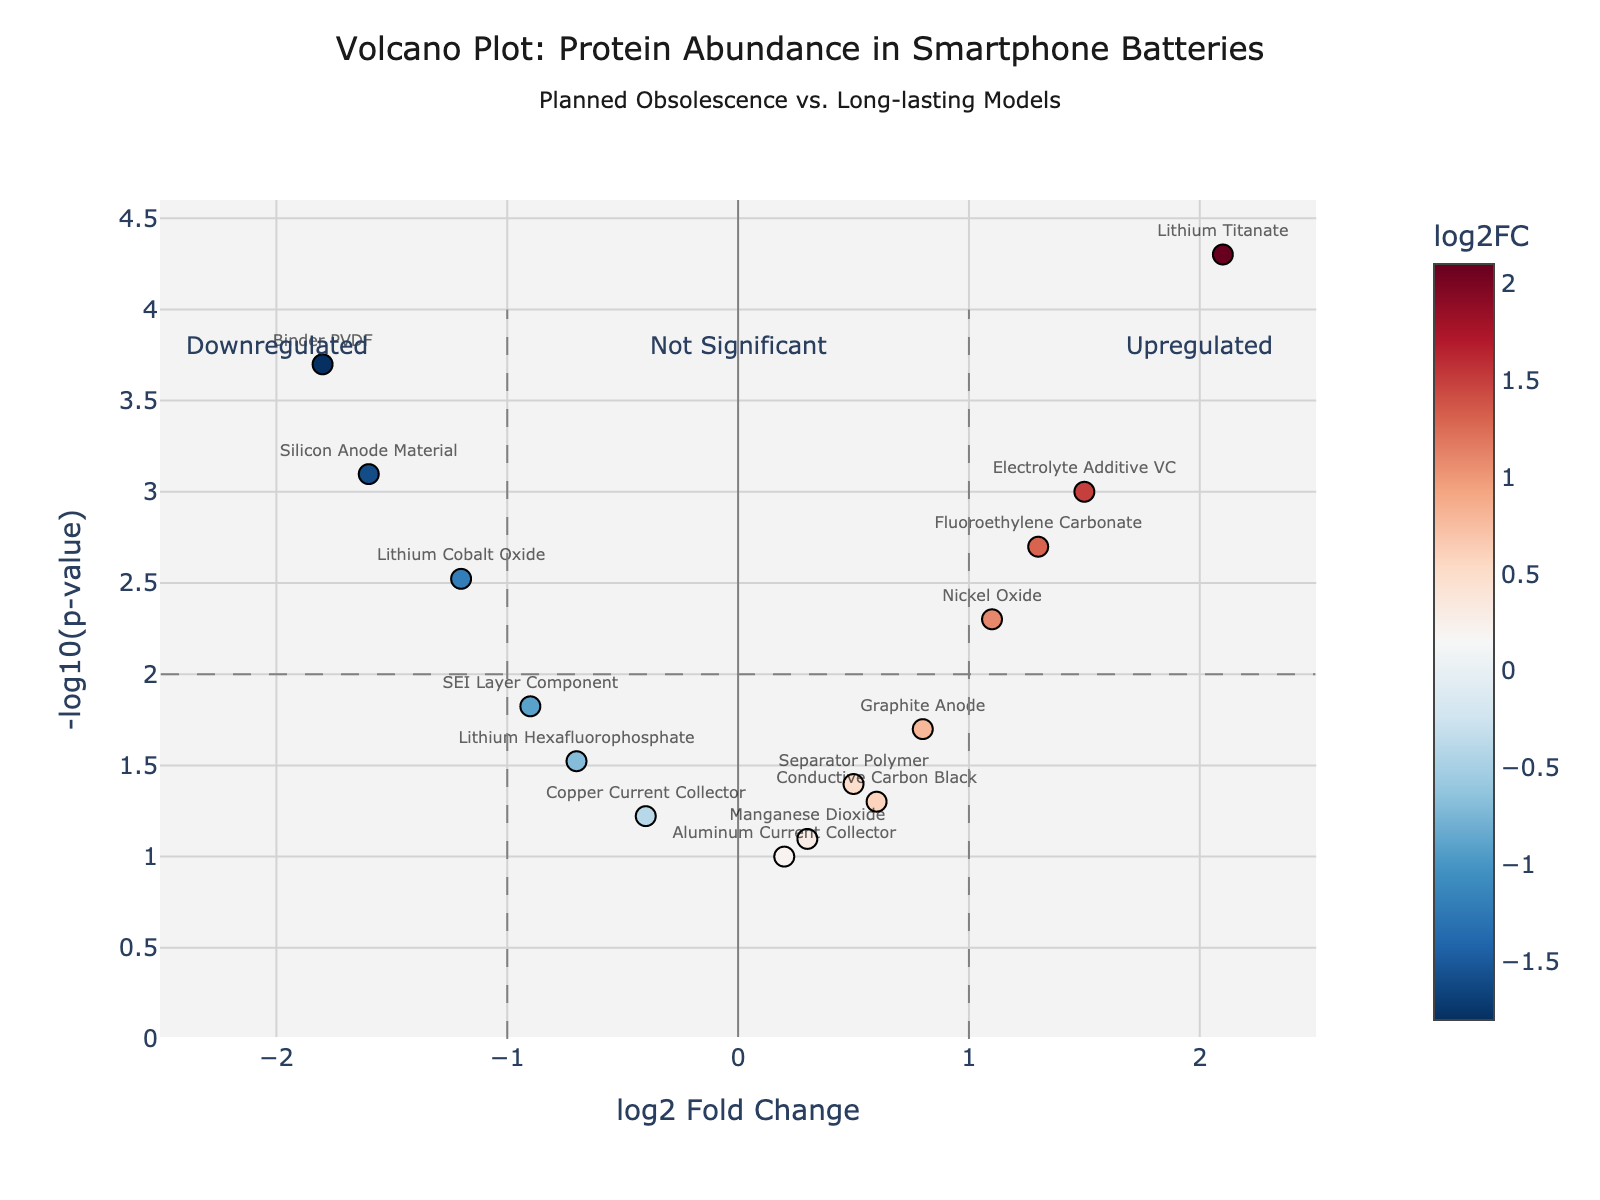What's the title of the plot? The title is usually displayed prominently at the top of the plot. Here, it reads: "Volcano Plot: Protein Abundance in Smartphone Batteries" with a subtitle "Planned Obsolescence vs. Long-lasting Models".
Answer: Volcano Plot: Protein Abundance in Smartphone Batteries What does the x-axis represent? The x-axis label is "log2 Fold Change," which indicates the logarithm base 2 of the fold change in protein abundance.
Answer: log2 Fold Change What does the y-axis represent? The y-axis label is "-log10(p-value)," which indicates the negative logarithm base 10 of the p-value.
Answer: -log10(p-value) How many proteins are significantly upregulated? Proteins are upregulated if their log2FoldChange is greater than 1 and significantly different if their -log10(p-value) is greater than 2. Based on the figure, Lithium Titanate, Fluoroethylene Carbonate, Nickel Oxide, and Electrolyte Additive VC meet these criteria.
Answer: 4 Which protein has the highest -log10(p-value)? By examining the text annotations and position on the y-axis, Lithium Titanate stands out as having the highest -log10(p-value).
Answer: Lithium Titanate Are there any proteins that are downregulated and significant? Downregulated signifies a log2FoldChange less than -1, and significant means -log10(p-value) greater than 2. Binder PVDF is noted for meeting these criteria.
Answer: Binder PVDF What is the log2FoldChange and p-value of Electrolyte Additive VC? Hovering over the marker for Electrolyte Additive VC shows its log2FC is approximately 1.5 and its p-value is 0.001.
Answer: log2FC: 1.5, p-value: 0.001 How does the protein Log2 Fold Change of Graphite Anode compare with Manganese Dioxide? Graphite Anode has a log2FoldChange of 0.8 while Manganese Dioxide has 0.3. 0.8 is greater than 0.3, indicating Graphite Anode has a higher log2FoldChange.
Answer: Graphite Anode has a higher log2FoldChange Which proteins fall into the "Not Significant" category? Proteins are "Not Significant" if their -log10(p-value) is less than or equal to 2. Manganese Dioxide, Copper Current Collector, Aluminum Current Collector, Binder PVDF, and Conductive Carbon Black fit this category.
Answer: 5 What color indicates a higher log2FoldChange on the color scale? The plot's color scheme (colorscale) is RdBu_r, traditionally ranging from red to blue in a continuous manner. In this case, red typically marks lower values and blue higher values. Blue indicates a higher log2FoldChange.
Answer: Blue 